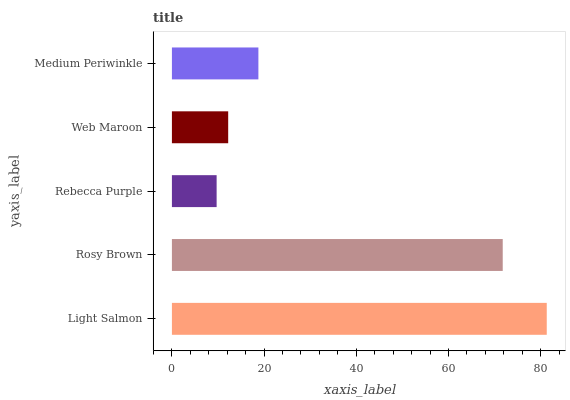Is Rebecca Purple the minimum?
Answer yes or no. Yes. Is Light Salmon the maximum?
Answer yes or no. Yes. Is Rosy Brown the minimum?
Answer yes or no. No. Is Rosy Brown the maximum?
Answer yes or no. No. Is Light Salmon greater than Rosy Brown?
Answer yes or no. Yes. Is Rosy Brown less than Light Salmon?
Answer yes or no. Yes. Is Rosy Brown greater than Light Salmon?
Answer yes or no. No. Is Light Salmon less than Rosy Brown?
Answer yes or no. No. Is Medium Periwinkle the high median?
Answer yes or no. Yes. Is Medium Periwinkle the low median?
Answer yes or no. Yes. Is Rosy Brown the high median?
Answer yes or no. No. Is Light Salmon the low median?
Answer yes or no. No. 